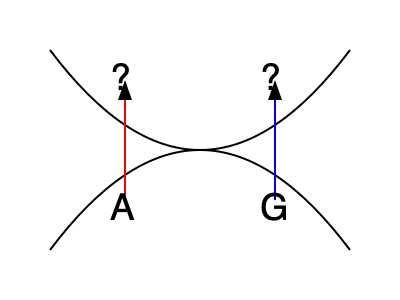In the DNA double helix structure shown above, base A is paired with an unknown base, and base G is paired with another unknown base. Given the complementary base pairing rules in DNA, what are the missing bases that should be paired with A and G, respectively? To solve this problem, we need to follow these steps:

1. Recall the complementary base pairing rules in DNA:
   - Adenine (A) pairs with Thymine (T)
   - Guanine (G) pairs with Cytosine (C)

2. Identify the given bases in the diagram:
   - We see an A (Adenine) on the bottom left
   - We see a G (Guanine) on the bottom right

3. Apply the base pairing rules:
   - A (Adenine) must pair with T (Thymine)
   - G (Guanine) must pair with C (Cytosine)

4. Determine the missing bases:
   - The base paired with A should be T
   - The base paired with G should be C

Therefore, the missing bases in the DNA double helix structure are T (paired with A) and C (paired with G).
Answer: T, C 